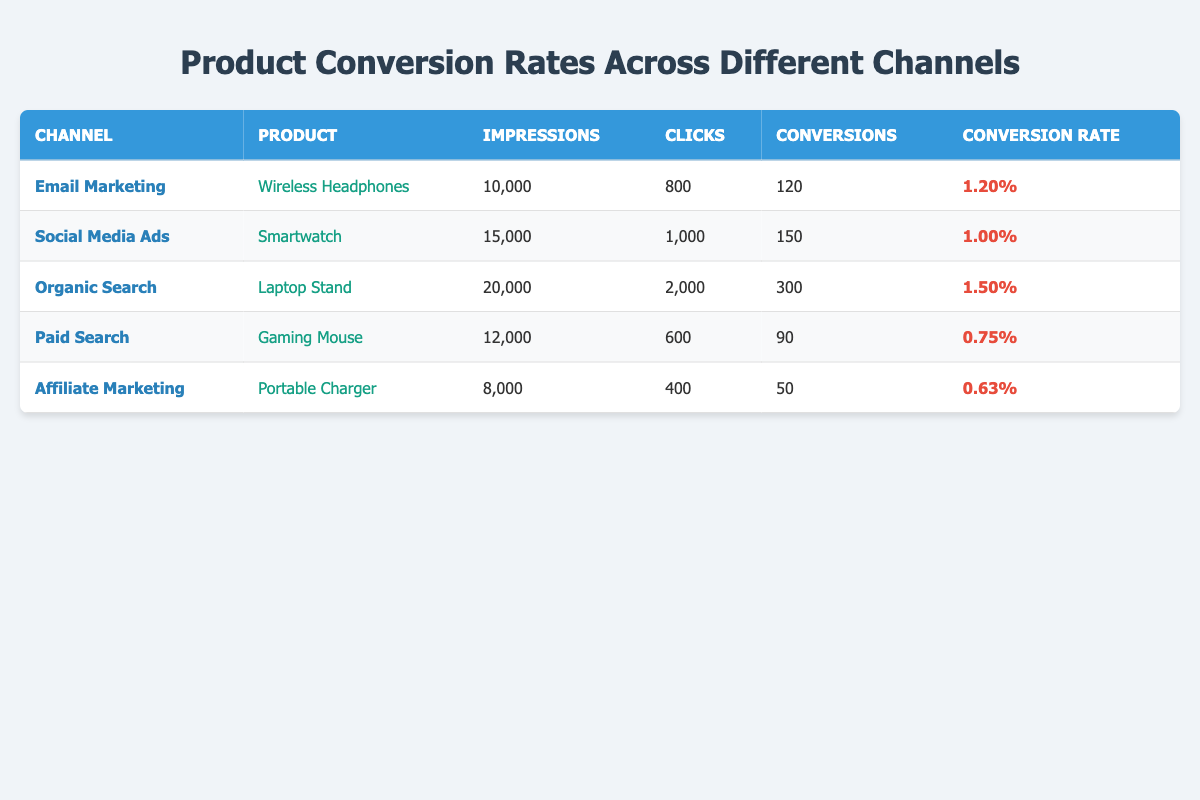What is the conversion rate for Email Marketing? The conversion rate for Email Marketing is listed directly in the table under the Conversion Rate column for that channel, which is 1.20%.
Answer: 1.20% Which product has the highest number of conversions? To find the product with the highest conversions, we look at the Conversions column in each row. The Laptop Stand has the highest number with 300 conversions.
Answer: Laptop Stand What are the total impressions for Paid Search and Affiliate Marketing? First, we find the impressions for Paid Search, which is 12000, and for Affiliate Marketing, which is 8000. Adding these together gives us 12000 + 8000 = 20000.
Answer: 20000 Is the conversion rate for Gaming Mouse higher than for Portable Charger? We compare the conversion rates from the table: Gaming Mouse has a rate of 0.75%, and Portable Charger has a rate of 0.63%. Since 0.75% is greater than 0.63%, the statement is true.
Answer: Yes Which channel has the lowest conversion rate? By examining the Conversion Rate column, we find the rates: Email Marketing (1.20%), Social Media Ads (1.00%), Organic Search (1.50%), Paid Search (0.75%), and Affiliate Marketing (0.63%). The lowest conversion rate is for Affiliate Marketing at 0.63%.
Answer: Affiliate Marketing What is the average number of clicks across all channels? To find the average clicks, we sum the clicks from each channel: 800 + 1000 + 2000 + 600 + 400 = 4800. Since there are 5 channels, the average is calculated as 4800 / 5 = 960.
Answer: 960 Are there any channels with a conversion rate of over 1%? Checking the Conversion Rate column, we see that Email Marketing (1.20%) and Organic Search (1.50%) both exceed 1%. Therefore, there are channels with such rates.
Answer: Yes How many more impressions does Organic Search have compared to Paid Search? The impressions for Organic Search are 20000, while Paid Search has 12000. Subtracting gives us 20000 - 12000 = 8000 more impressions.
Answer: 8000 What is the total number of conversions for all channels combined? We add up the conversions for each channel: 120 + 150 + 300 + 90 + 50 = 710. This gives us the total number of conversions across all channels.
Answer: 710 